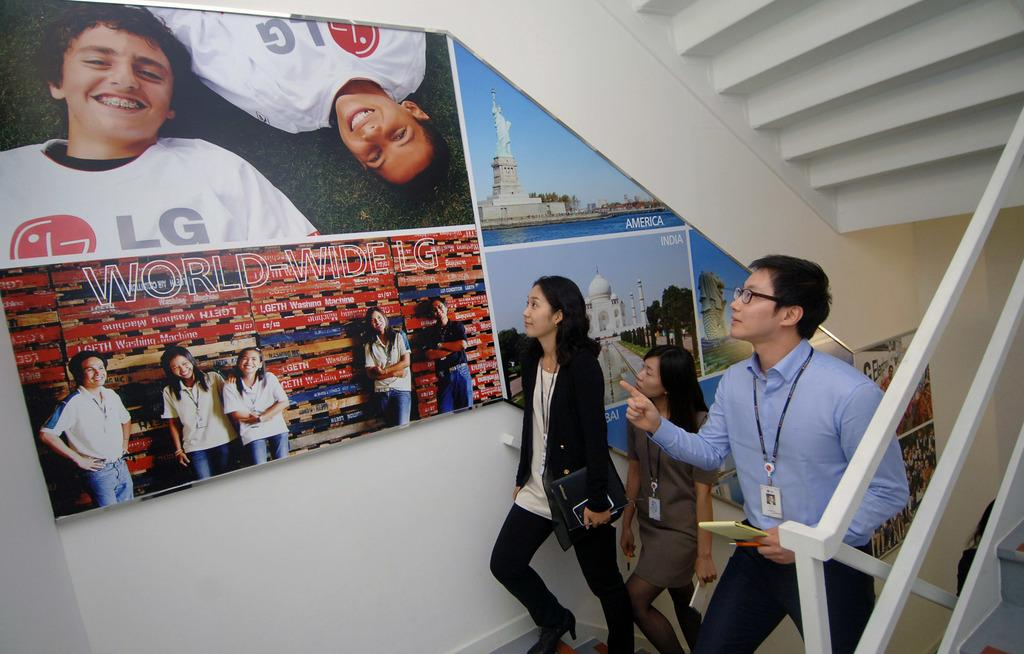Who or what is present in the image? There are people in the image. What are the people wearing in the image? The people are wearing ID cards in the image. What can be seen in the background of the image? There are posts on the wall in the background of the image. What type of soap is being used by the people in the image? There is no soap present in the image; the people are wearing ID cards. What is the base material of the recess in the image? There is no recess present in the image; the background features posts on the wall. 